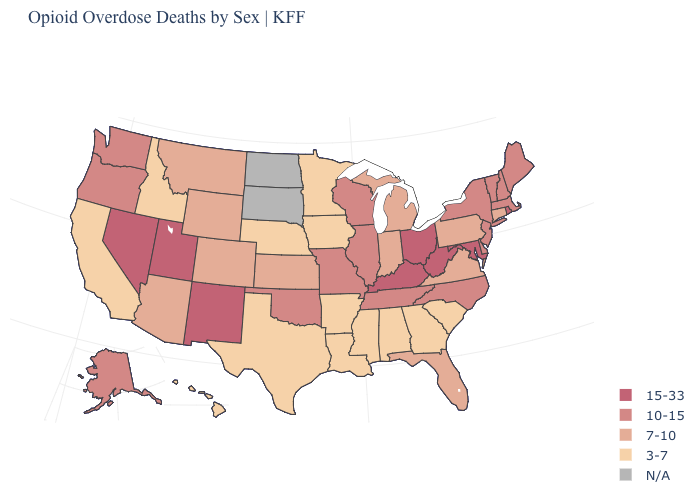Does the map have missing data?
Concise answer only. Yes. Which states have the lowest value in the USA?
Answer briefly. Alabama, Arkansas, California, Georgia, Hawaii, Idaho, Iowa, Louisiana, Minnesota, Mississippi, Nebraska, South Carolina, Texas. What is the value of Kentucky?
Give a very brief answer. 15-33. Among the states that border Wyoming , does Montana have the highest value?
Be succinct. No. Which states have the lowest value in the USA?
Concise answer only. Alabama, Arkansas, California, Georgia, Hawaii, Idaho, Iowa, Louisiana, Minnesota, Mississippi, Nebraska, South Carolina, Texas. Name the states that have a value in the range 7-10?
Be succinct. Arizona, Colorado, Connecticut, Florida, Indiana, Kansas, Michigan, Montana, Pennsylvania, Virginia, Wyoming. Among the states that border Arkansas , which have the highest value?
Concise answer only. Missouri, Oklahoma, Tennessee. Does West Virginia have the lowest value in the USA?
Short answer required. No. How many symbols are there in the legend?
Short answer required. 5. Does Oklahoma have the highest value in the South?
Short answer required. No. Among the states that border Wisconsin , does Michigan have the lowest value?
Write a very short answer. No. Which states hav the highest value in the Northeast?
Concise answer only. Rhode Island. Which states have the highest value in the USA?
Answer briefly. Kentucky, Maryland, Nevada, New Mexico, Ohio, Rhode Island, Utah, West Virginia. 